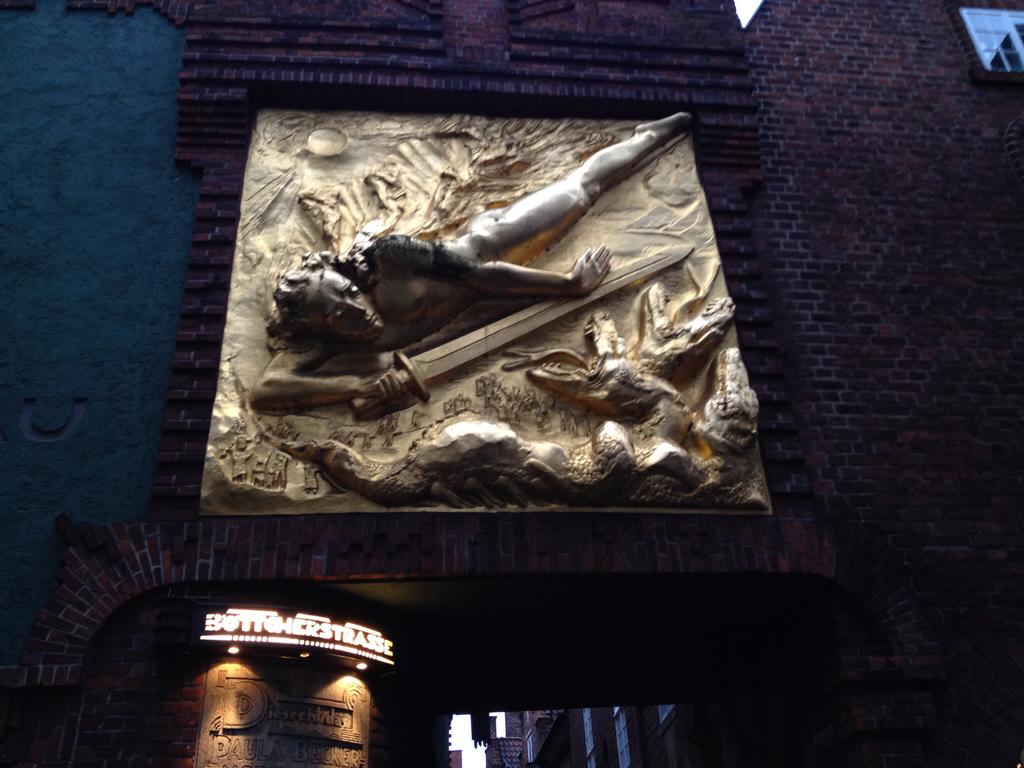What is the main subject of the image? The main subject of the image is a building. Can you describe the building's architectural structure? Yes, the building has an architectural structure. What is located beneath the building? There is a name display beneath the building. What feature does the name display have? The name display has lights. What type of disease is being treated in the building in the image? There is no indication of a disease or any medical treatment in the image; it simply features a building with a name display beneath it. 